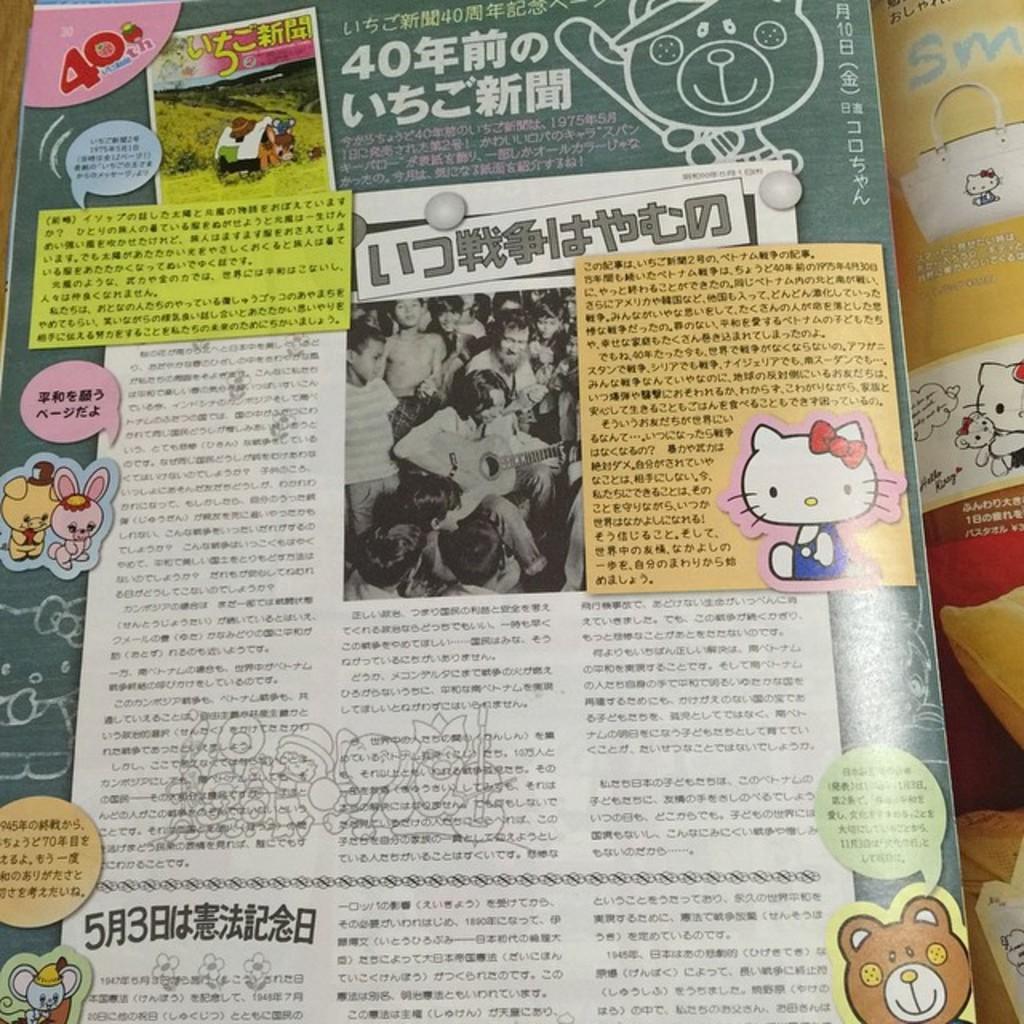Please provide a concise description of this image. In this image I see a paper on which there are cartoon pictures and I see something is written and I see a picture over here in which there are number of people and I see that a person is holding a guitar and I see something is written over here too and I see few more cartoon pictures over here. 